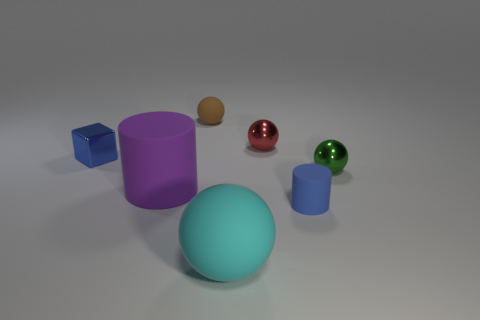Subtract all yellow balls. Subtract all gray cubes. How many balls are left? 4 Add 1 red matte cylinders. How many objects exist? 8 Subtract all cylinders. How many objects are left? 5 Add 6 shiny things. How many shiny things are left? 9 Add 4 cylinders. How many cylinders exist? 6 Subtract 0 cyan cylinders. How many objects are left? 7 Subtract all small blue cubes. Subtract all small gray things. How many objects are left? 6 